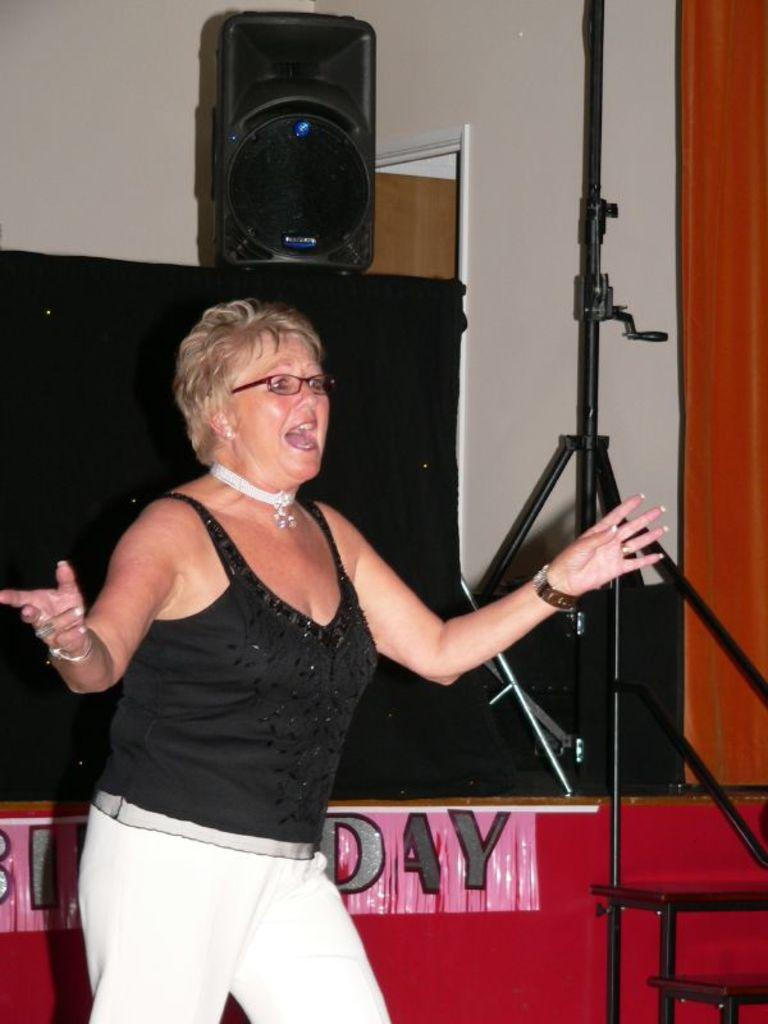<image>
Give a short and clear explanation of the subsequent image. A woman singing in front of a birthday sign. 